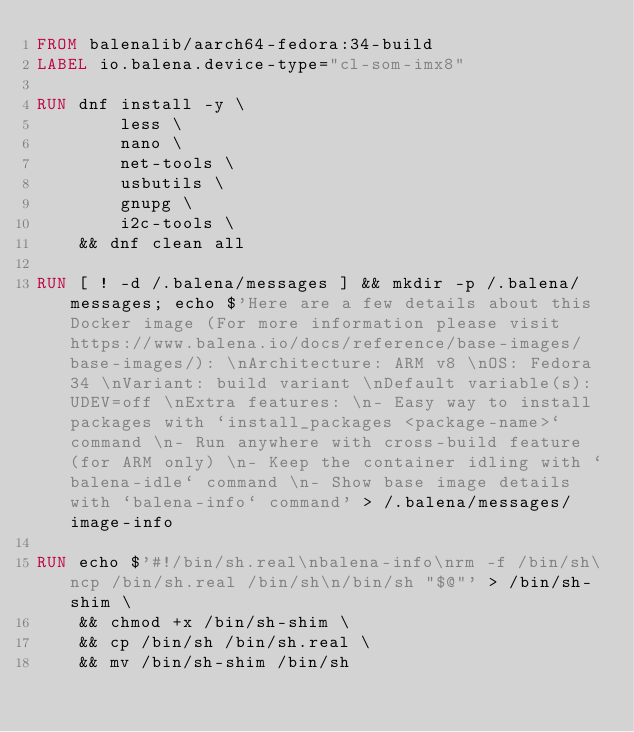Convert code to text. <code><loc_0><loc_0><loc_500><loc_500><_Dockerfile_>FROM balenalib/aarch64-fedora:34-build
LABEL io.balena.device-type="cl-som-imx8"

RUN dnf install -y \
		less \
		nano \
		net-tools \
		usbutils \
		gnupg \
		i2c-tools \
	&& dnf clean all

RUN [ ! -d /.balena/messages ] && mkdir -p /.balena/messages; echo $'Here are a few details about this Docker image (For more information please visit https://www.balena.io/docs/reference/base-images/base-images/): \nArchitecture: ARM v8 \nOS: Fedora 34 \nVariant: build variant \nDefault variable(s): UDEV=off \nExtra features: \n- Easy way to install packages with `install_packages <package-name>` command \n- Run anywhere with cross-build feature  (for ARM only) \n- Keep the container idling with `balena-idle` command \n- Show base image details with `balena-info` command' > /.balena/messages/image-info

RUN echo $'#!/bin/sh.real\nbalena-info\nrm -f /bin/sh\ncp /bin/sh.real /bin/sh\n/bin/sh "$@"' > /bin/sh-shim \
	&& chmod +x /bin/sh-shim \
	&& cp /bin/sh /bin/sh.real \
	&& mv /bin/sh-shim /bin/sh</code> 